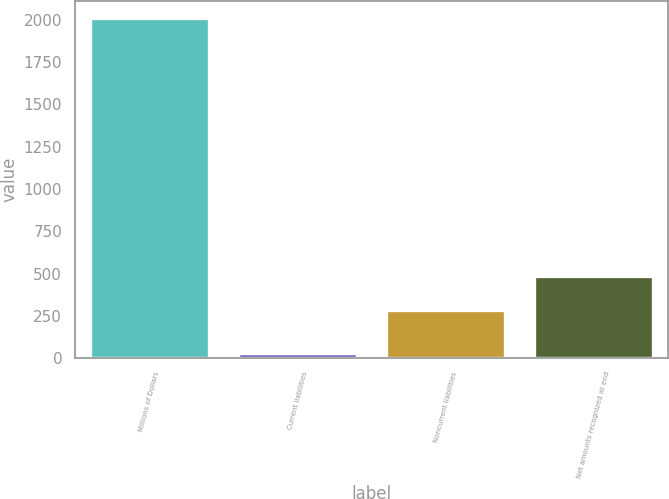Convert chart. <chart><loc_0><loc_0><loc_500><loc_500><bar_chart><fcel>Millions of Dollars<fcel>Current liabilities<fcel>Noncurrent liabilities<fcel>Net amounts recognized at end<nl><fcel>2009<fcel>28<fcel>286<fcel>484.1<nl></chart> 